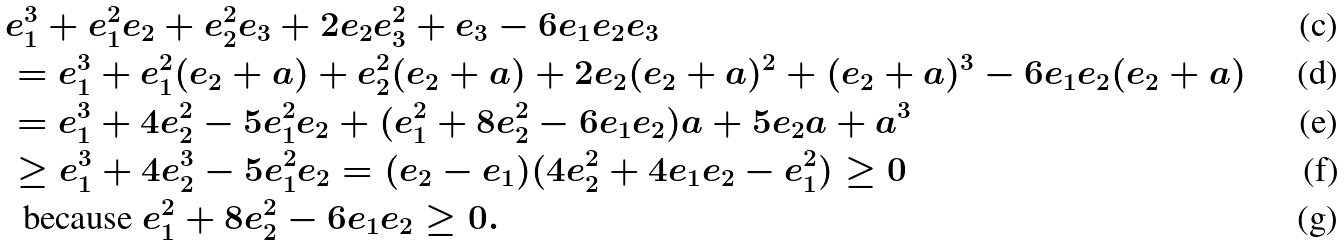Convert formula to latex. <formula><loc_0><loc_0><loc_500><loc_500>& e _ { 1 } ^ { 3 } + e _ { 1 } ^ { 2 } e _ { 2 } + e _ { 2 } ^ { 2 } e _ { 3 } + 2 e _ { 2 } e _ { 3 } ^ { 2 } + e _ { 3 } - 6 e _ { 1 } e _ { 2 } e _ { 3 } \\ & = e _ { 1 } ^ { 3 } + e _ { 1 } ^ { 2 } ( e _ { 2 } + a ) + e _ { 2 } ^ { 2 } ( e _ { 2 } + a ) + 2 e _ { 2 } ( e _ { 2 } + a ) ^ { 2 } + ( e _ { 2 } + a ) ^ { 3 } - 6 e _ { 1 } e _ { 2 } ( e _ { 2 } + a ) \\ & = e _ { 1 } ^ { 3 } + 4 e _ { 2 } ^ { 2 } - 5 e _ { 1 } ^ { 2 } e _ { 2 } + ( e _ { 1 } ^ { 2 } + 8 e _ { 2 } ^ { 2 } - 6 e _ { 1 } e _ { 2 } ) a + 5 e _ { 2 } a + a ^ { 3 } \\ & \geq e _ { 1 } ^ { 3 } + 4 e _ { 2 } ^ { 3 } - 5 e _ { 1 } ^ { 2 } e _ { 2 } = ( e _ { 2 } - e _ { 1 } ) ( 4 e _ { 2 } ^ { 2 } + 4 e _ { 1 } e _ { 2 } - e _ { 1 } ^ { 2 } ) \geq 0 \\ & \ \text { because } e _ { 1 } ^ { 2 } + 8 e _ { 2 } ^ { 2 } - 6 e _ { 1 } e _ { 2 } \geq 0 .</formula> 